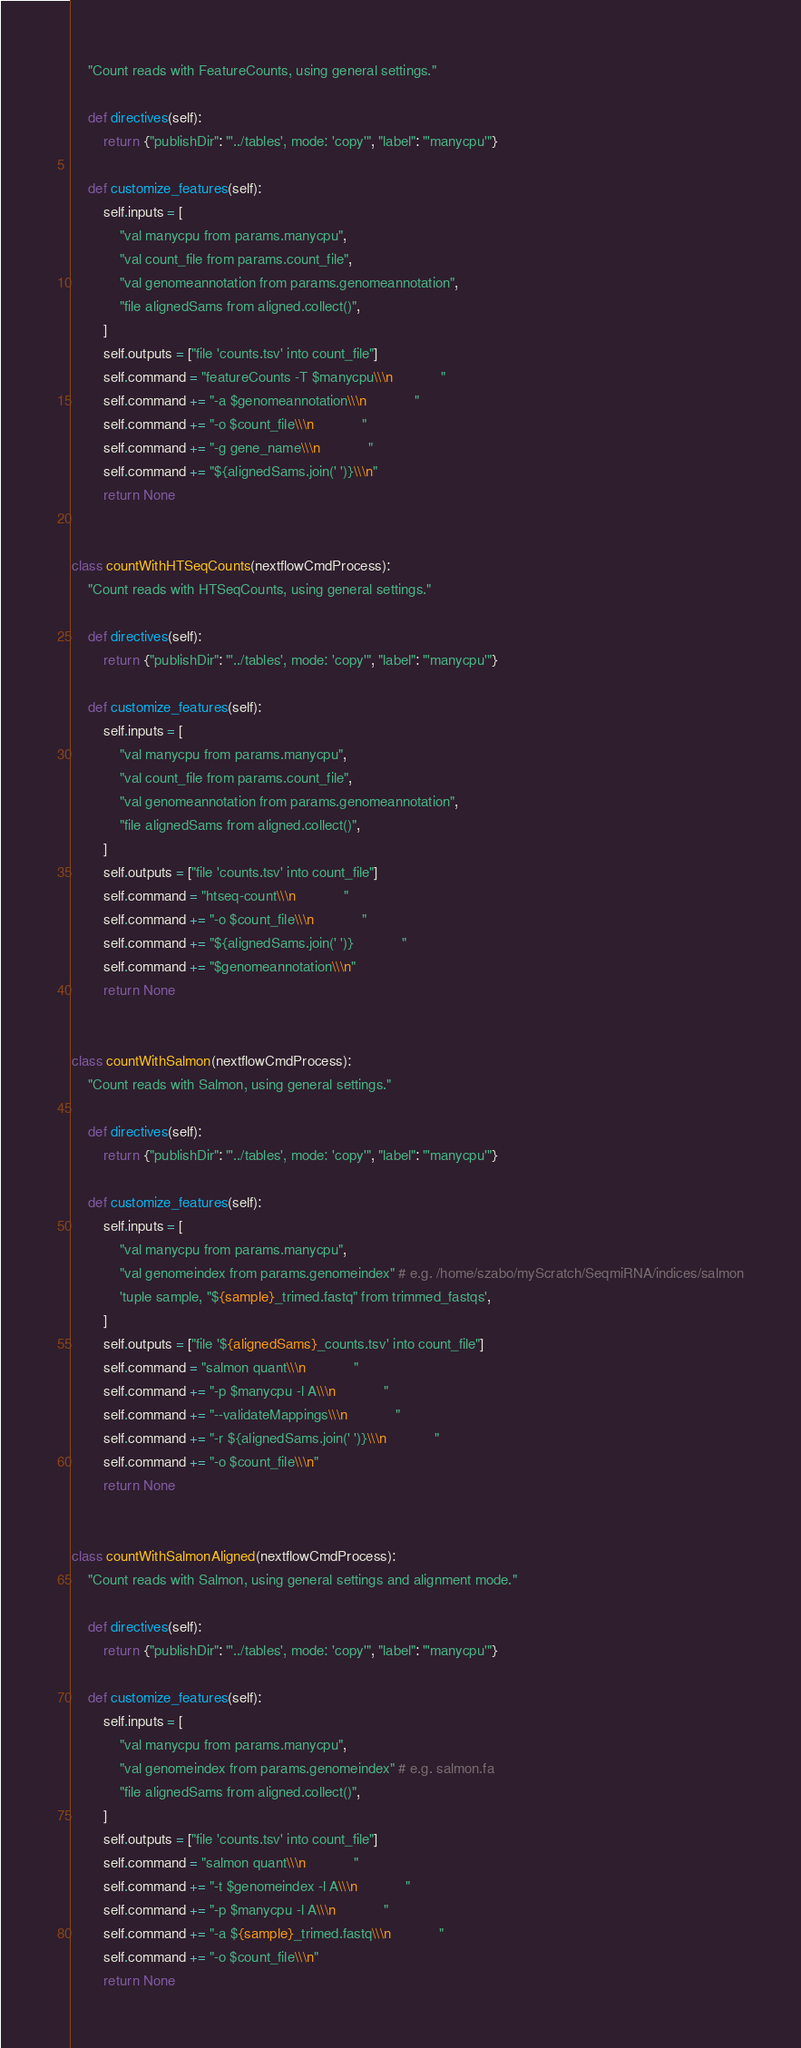<code> <loc_0><loc_0><loc_500><loc_500><_Python_>    "Count reads with FeatureCounts, using general settings."

    def directives(self):
        return {"publishDir": "'../tables', mode: 'copy'", "label": "'manycpu'"}

    def customize_features(self):
        self.inputs = [
            "val manycpu from params.manycpu",
            "val count_file from params.count_file",
            "val genomeannotation from params.genomeannotation",
            "file alignedSams from aligned.collect()",
        ]
        self.outputs = ["file 'counts.tsv' into count_file"]
        self.command = "featureCounts -T $manycpu\\\n            "
        self.command += "-a $genomeannotation\\\n            "
        self.command += "-o $count_file\\\n            "
        self.command += "-g gene_name\\\n            "
        self.command += "${alignedSams.join(' ')}\\\n"
        return None


class countWithHTSeqCounts(nextflowCmdProcess):
    "Count reads with HTSeqCounts, using general settings."

    def directives(self):
        return {"publishDir": "'../tables', mode: 'copy'", "label": "'manycpu'"}

    def customize_features(self):
        self.inputs = [
            "val manycpu from params.manycpu",
            "val count_file from params.count_file",
            "val genomeannotation from params.genomeannotation",
            "file alignedSams from aligned.collect()",
        ]
        self.outputs = ["file 'counts.tsv' into count_file"]
        self.command = "htseq-count\\\n            "
        self.command += "-o $count_file\\\n            "
        self.command += "${alignedSams.join(' ')}            "
        self.command += "$genomeannotation\\\n"
        return None


class countWithSalmon(nextflowCmdProcess):
    "Count reads with Salmon, using general settings."

    def directives(self):
        return {"publishDir": "'../tables', mode: 'copy'", "label": "'manycpu'"}

    def customize_features(self):
        self.inputs = [
            "val manycpu from params.manycpu",
            "val genomeindex from params.genomeindex" # e.g. /home/szabo/myScratch/SeqmiRNA/indices/salmon
            'tuple sample, "${sample}_trimed.fastq" from trimmed_fastqs',
        ]
        self.outputs = ["file '${alignedSams}_counts.tsv' into count_file"]
        self.command = "salmon quant\\\n            "
        self.command += "-p $manycpu -l A\\\n            "
        self.command += "--validateMappings\\\n            "
        self.command += "-r ${alignedSams.join(' ')}\\\n            "
        self.command += "-o $count_file\\\n"
        return None

    
class countWithSalmonAligned(nextflowCmdProcess):
    "Count reads with Salmon, using general settings and alignment mode."

    def directives(self):
        return {"publishDir": "'../tables', mode: 'copy'", "label": "'manycpu'"}

    def customize_features(self):
        self.inputs = [
            "val manycpu from params.manycpu",
            "val genomeindex from params.genomeindex" # e.g. salmon.fa
            "file alignedSams from aligned.collect()",
        ]
        self.outputs = ["file 'counts.tsv' into count_file"]
        self.command = "salmon quant\\\n            "
        self.command += "-t $genomeindex -l A\\\n            "
        self.command += "-p $manycpu -l A\\\n            "
        self.command += "-a ${sample}_trimed.fastq\\\n            "
        self.command += "-o $count_file\\\n"
        return None
</code> 